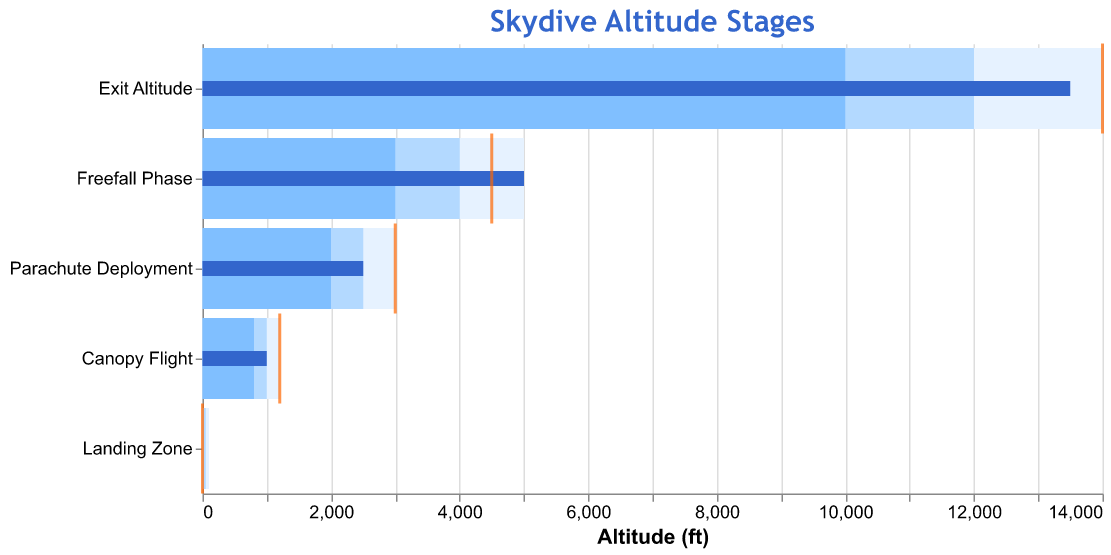How many stages of altitude are shown in the figure? The figure has data points for different stages of altitude - "Exit Altitude", "Freefall Phase", "Parachute Deployment", "Canopy Flight”, and "Landing Zone"
Answer: 5 What is the target altitude for the "Freefall Phase"? By locating the “Freefall Phase” on the y-axis and following it horizontally to the orange tick mark which represents the target altitude, we see the target altitude is 4500 feet.
Answer: 4500 feet Which stage has the highest actual altitude? To determine the highest actual altitude, look for the longest blue bar. The "Exit Altitude" stage has the longest blue bar, indicating it has the highest actual altitude.
Answer: Exit Altitude What's the difference between the actual and target altitude for "Parachute Deployment"? The target altitude is 3000 feet, and the actual altitude is 2500 feet. Calculating the difference: 3000 - 2500 = 500
Answer: 500 feet Is the "Canopy Flight" actual altitude within its target range? For "Canopy Flight", the actual altitude is 1000 feet, while the target range is from 800 to 1200 feet. Since 1000 is within this range, it is indeed within the target range.
Answer: Yes Which stage has the smallest target range span? The target ranges are visualized by the lighter blue bars. "Landing Zone" has the span from 0 to 100 feet. This is a range of 100 feet, which is the smallest span among all stages.
Answer: Landing Zone How much higher is the exit altitude compared to the freefall phase actual altitude? The exit altitude actual value is 13500 feet, and the freefall phase actual value is 5000 feet. The difference is 13500 - 5000 = 8500 feet.
Answer: 8500 feet Does any stage have an actual altitude exactly equal to its target altitude? By examining each stage and comparing the length of the blue bar (actual) with the position of the orange tick mark (target), only "Landing Zone" has both an actual altitude and target altitude of 0 feet.
Answer: Yes For "Parachute Deployment", what is the middle value of its range? The range for this stage is from 2000 to 3000 feet. The middle value is the average, calculated as (2000 + 3000)/2 = 2500 feet.
Answer: 2500 feet Which stage’s actual value deviates the most from its target? The deviation can be determined by calculating the absolute difference for each stage. The largest deviation is between the target and actual values at "Exit Altitude": 14000 - 13500 = 500 feet, which exceeds deviations in other stages.
Answer: Exit Altitude 